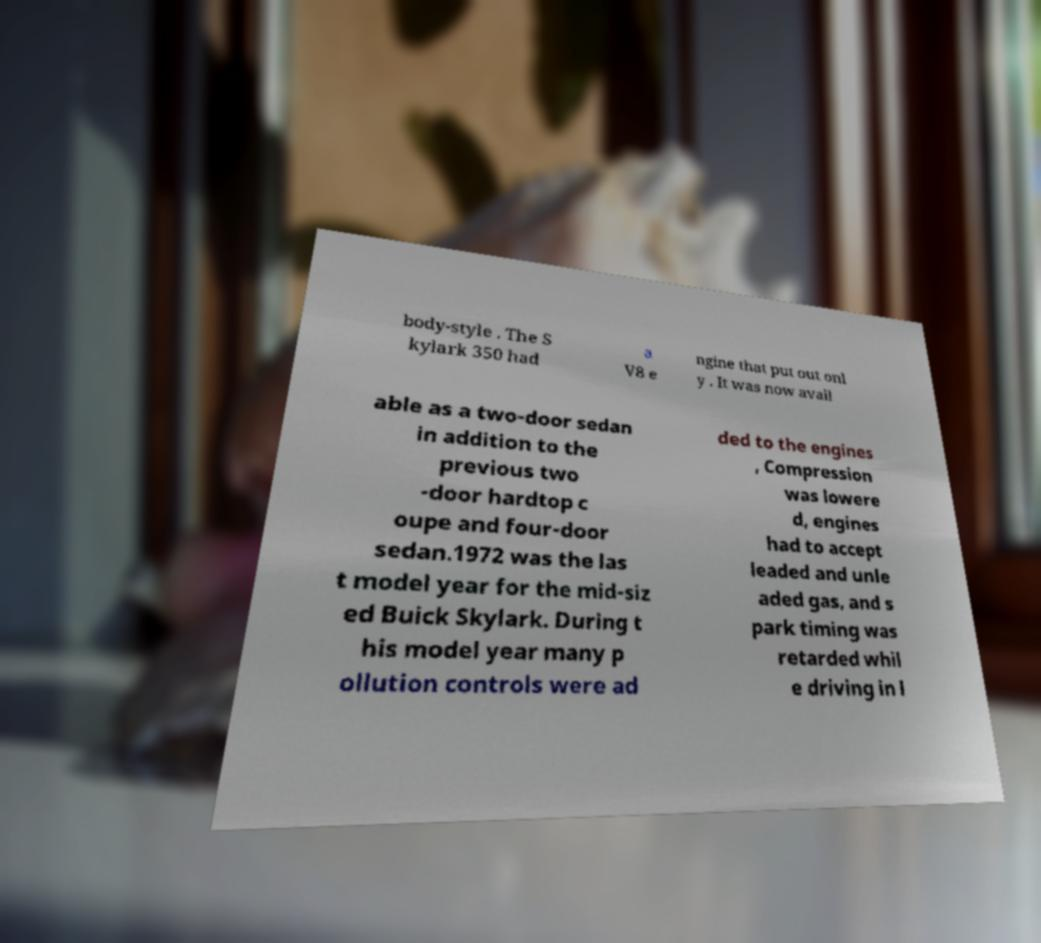Can you accurately transcribe the text from the provided image for me? body-style . The S kylark 350 had a V8 e ngine that put out onl y . It was now avail able as a two-door sedan in addition to the previous two -door hardtop c oupe and four-door sedan.1972 was the las t model year for the mid-siz ed Buick Skylark. During t his model year many p ollution controls were ad ded to the engines , Compression was lowere d, engines had to accept leaded and unle aded gas, and s park timing was retarded whil e driving in l 